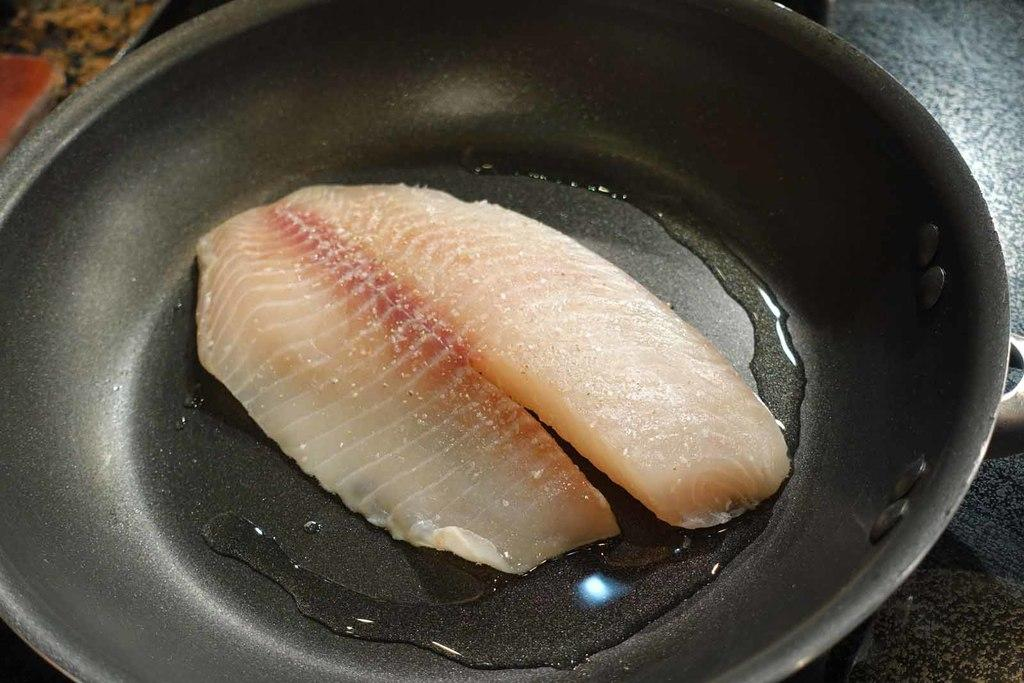What type of food is in the image? There is a piece of fish in the image. What is the fish placed in? The fish is in a black color pan. What is present in the pan with the fish? There is oil in the pan with the fish. How often does your uncle visit the coast during the week? There is no information about an uncle or the coast in the image, so this question cannot be answered based on the provided facts. 